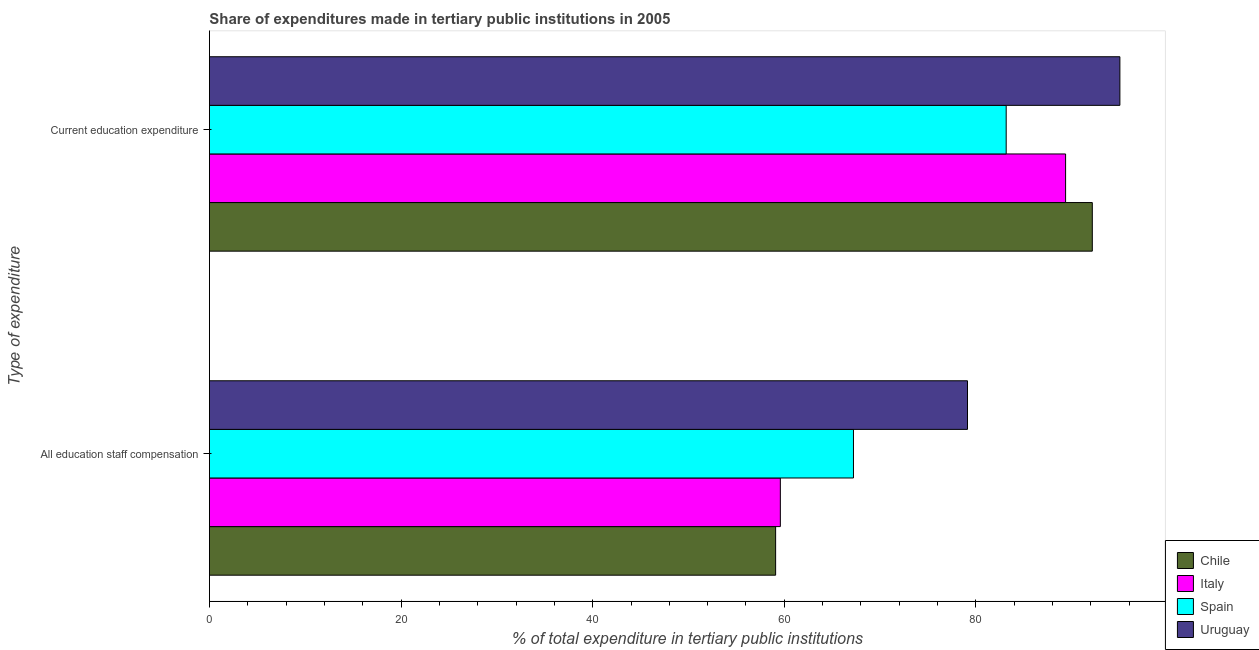How many different coloured bars are there?
Offer a very short reply. 4. Are the number of bars per tick equal to the number of legend labels?
Provide a succinct answer. Yes. Are the number of bars on each tick of the Y-axis equal?
Your answer should be very brief. Yes. What is the label of the 2nd group of bars from the top?
Give a very brief answer. All education staff compensation. What is the expenditure in education in Spain?
Your answer should be compact. 83.16. Across all countries, what is the maximum expenditure in staff compensation?
Offer a terse response. 79.12. Across all countries, what is the minimum expenditure in staff compensation?
Your response must be concise. 59.09. In which country was the expenditure in staff compensation maximum?
Your answer should be very brief. Uruguay. In which country was the expenditure in staff compensation minimum?
Offer a very short reply. Chile. What is the total expenditure in education in the graph?
Provide a short and direct response. 359.68. What is the difference between the expenditure in staff compensation in Uruguay and that in Spain?
Ensure brevity in your answer.  11.9. What is the difference between the expenditure in staff compensation in Spain and the expenditure in education in Italy?
Give a very brief answer. -22.14. What is the average expenditure in education per country?
Your answer should be compact. 89.92. What is the difference between the expenditure in education and expenditure in staff compensation in Spain?
Ensure brevity in your answer.  15.94. What is the ratio of the expenditure in education in Uruguay to that in Chile?
Provide a short and direct response. 1.03. Is the expenditure in education in Spain less than that in Uruguay?
Your response must be concise. Yes. Does the graph contain grids?
Your answer should be compact. No. How are the legend labels stacked?
Make the answer very short. Vertical. What is the title of the graph?
Give a very brief answer. Share of expenditures made in tertiary public institutions in 2005. What is the label or title of the X-axis?
Your answer should be very brief. % of total expenditure in tertiary public institutions. What is the label or title of the Y-axis?
Offer a terse response. Type of expenditure. What is the % of total expenditure in tertiary public institutions of Chile in All education staff compensation?
Your answer should be very brief. 59.09. What is the % of total expenditure in tertiary public institutions of Italy in All education staff compensation?
Your answer should be compact. 59.59. What is the % of total expenditure in tertiary public institutions in Spain in All education staff compensation?
Offer a terse response. 67.22. What is the % of total expenditure in tertiary public institutions of Uruguay in All education staff compensation?
Ensure brevity in your answer.  79.12. What is the % of total expenditure in tertiary public institutions in Chile in Current education expenditure?
Give a very brief answer. 92.14. What is the % of total expenditure in tertiary public institutions of Italy in Current education expenditure?
Ensure brevity in your answer.  89.36. What is the % of total expenditure in tertiary public institutions in Spain in Current education expenditure?
Offer a terse response. 83.16. What is the % of total expenditure in tertiary public institutions of Uruguay in Current education expenditure?
Offer a very short reply. 95.02. Across all Type of expenditure, what is the maximum % of total expenditure in tertiary public institutions in Chile?
Give a very brief answer. 92.14. Across all Type of expenditure, what is the maximum % of total expenditure in tertiary public institutions of Italy?
Offer a terse response. 89.36. Across all Type of expenditure, what is the maximum % of total expenditure in tertiary public institutions in Spain?
Make the answer very short. 83.16. Across all Type of expenditure, what is the maximum % of total expenditure in tertiary public institutions in Uruguay?
Make the answer very short. 95.02. Across all Type of expenditure, what is the minimum % of total expenditure in tertiary public institutions in Chile?
Offer a terse response. 59.09. Across all Type of expenditure, what is the minimum % of total expenditure in tertiary public institutions in Italy?
Your answer should be compact. 59.59. Across all Type of expenditure, what is the minimum % of total expenditure in tertiary public institutions of Spain?
Offer a very short reply. 67.22. Across all Type of expenditure, what is the minimum % of total expenditure in tertiary public institutions of Uruguay?
Ensure brevity in your answer.  79.12. What is the total % of total expenditure in tertiary public institutions in Chile in the graph?
Offer a terse response. 151.24. What is the total % of total expenditure in tertiary public institutions in Italy in the graph?
Provide a short and direct response. 148.94. What is the total % of total expenditure in tertiary public institutions of Spain in the graph?
Provide a succinct answer. 150.37. What is the total % of total expenditure in tertiary public institutions in Uruguay in the graph?
Offer a very short reply. 174.14. What is the difference between the % of total expenditure in tertiary public institutions of Chile in All education staff compensation and that in Current education expenditure?
Your answer should be compact. -33.05. What is the difference between the % of total expenditure in tertiary public institutions in Italy in All education staff compensation and that in Current education expenditure?
Offer a terse response. -29.77. What is the difference between the % of total expenditure in tertiary public institutions in Spain in All education staff compensation and that in Current education expenditure?
Make the answer very short. -15.94. What is the difference between the % of total expenditure in tertiary public institutions of Uruguay in All education staff compensation and that in Current education expenditure?
Offer a very short reply. -15.9. What is the difference between the % of total expenditure in tertiary public institutions of Chile in All education staff compensation and the % of total expenditure in tertiary public institutions of Italy in Current education expenditure?
Your answer should be compact. -30.26. What is the difference between the % of total expenditure in tertiary public institutions of Chile in All education staff compensation and the % of total expenditure in tertiary public institutions of Spain in Current education expenditure?
Offer a very short reply. -24.06. What is the difference between the % of total expenditure in tertiary public institutions in Chile in All education staff compensation and the % of total expenditure in tertiary public institutions in Uruguay in Current education expenditure?
Provide a succinct answer. -35.93. What is the difference between the % of total expenditure in tertiary public institutions in Italy in All education staff compensation and the % of total expenditure in tertiary public institutions in Spain in Current education expenditure?
Keep it short and to the point. -23.57. What is the difference between the % of total expenditure in tertiary public institutions in Italy in All education staff compensation and the % of total expenditure in tertiary public institutions in Uruguay in Current education expenditure?
Your answer should be very brief. -35.44. What is the difference between the % of total expenditure in tertiary public institutions of Spain in All education staff compensation and the % of total expenditure in tertiary public institutions of Uruguay in Current education expenditure?
Provide a succinct answer. -27.81. What is the average % of total expenditure in tertiary public institutions of Chile per Type of expenditure?
Keep it short and to the point. 75.62. What is the average % of total expenditure in tertiary public institutions in Italy per Type of expenditure?
Offer a terse response. 74.47. What is the average % of total expenditure in tertiary public institutions in Spain per Type of expenditure?
Your answer should be very brief. 75.19. What is the average % of total expenditure in tertiary public institutions in Uruguay per Type of expenditure?
Ensure brevity in your answer.  87.07. What is the difference between the % of total expenditure in tertiary public institutions in Chile and % of total expenditure in tertiary public institutions in Italy in All education staff compensation?
Offer a terse response. -0.49. What is the difference between the % of total expenditure in tertiary public institutions in Chile and % of total expenditure in tertiary public institutions in Spain in All education staff compensation?
Make the answer very short. -8.12. What is the difference between the % of total expenditure in tertiary public institutions of Chile and % of total expenditure in tertiary public institutions of Uruguay in All education staff compensation?
Provide a succinct answer. -20.02. What is the difference between the % of total expenditure in tertiary public institutions in Italy and % of total expenditure in tertiary public institutions in Spain in All education staff compensation?
Your response must be concise. -7.63. What is the difference between the % of total expenditure in tertiary public institutions in Italy and % of total expenditure in tertiary public institutions in Uruguay in All education staff compensation?
Offer a terse response. -19.53. What is the difference between the % of total expenditure in tertiary public institutions of Spain and % of total expenditure in tertiary public institutions of Uruguay in All education staff compensation?
Keep it short and to the point. -11.9. What is the difference between the % of total expenditure in tertiary public institutions of Chile and % of total expenditure in tertiary public institutions of Italy in Current education expenditure?
Offer a terse response. 2.79. What is the difference between the % of total expenditure in tertiary public institutions of Chile and % of total expenditure in tertiary public institutions of Spain in Current education expenditure?
Ensure brevity in your answer.  8.99. What is the difference between the % of total expenditure in tertiary public institutions of Chile and % of total expenditure in tertiary public institutions of Uruguay in Current education expenditure?
Provide a succinct answer. -2.88. What is the difference between the % of total expenditure in tertiary public institutions in Italy and % of total expenditure in tertiary public institutions in Spain in Current education expenditure?
Ensure brevity in your answer.  6.2. What is the difference between the % of total expenditure in tertiary public institutions of Italy and % of total expenditure in tertiary public institutions of Uruguay in Current education expenditure?
Offer a terse response. -5.67. What is the difference between the % of total expenditure in tertiary public institutions in Spain and % of total expenditure in tertiary public institutions in Uruguay in Current education expenditure?
Your response must be concise. -11.87. What is the ratio of the % of total expenditure in tertiary public institutions in Chile in All education staff compensation to that in Current education expenditure?
Make the answer very short. 0.64. What is the ratio of the % of total expenditure in tertiary public institutions of Italy in All education staff compensation to that in Current education expenditure?
Ensure brevity in your answer.  0.67. What is the ratio of the % of total expenditure in tertiary public institutions in Spain in All education staff compensation to that in Current education expenditure?
Your answer should be very brief. 0.81. What is the ratio of the % of total expenditure in tertiary public institutions in Uruguay in All education staff compensation to that in Current education expenditure?
Ensure brevity in your answer.  0.83. What is the difference between the highest and the second highest % of total expenditure in tertiary public institutions of Chile?
Give a very brief answer. 33.05. What is the difference between the highest and the second highest % of total expenditure in tertiary public institutions in Italy?
Offer a terse response. 29.77. What is the difference between the highest and the second highest % of total expenditure in tertiary public institutions of Spain?
Keep it short and to the point. 15.94. What is the difference between the highest and the second highest % of total expenditure in tertiary public institutions in Uruguay?
Offer a very short reply. 15.9. What is the difference between the highest and the lowest % of total expenditure in tertiary public institutions of Chile?
Give a very brief answer. 33.05. What is the difference between the highest and the lowest % of total expenditure in tertiary public institutions in Italy?
Your response must be concise. 29.77. What is the difference between the highest and the lowest % of total expenditure in tertiary public institutions of Spain?
Give a very brief answer. 15.94. What is the difference between the highest and the lowest % of total expenditure in tertiary public institutions of Uruguay?
Your answer should be very brief. 15.9. 